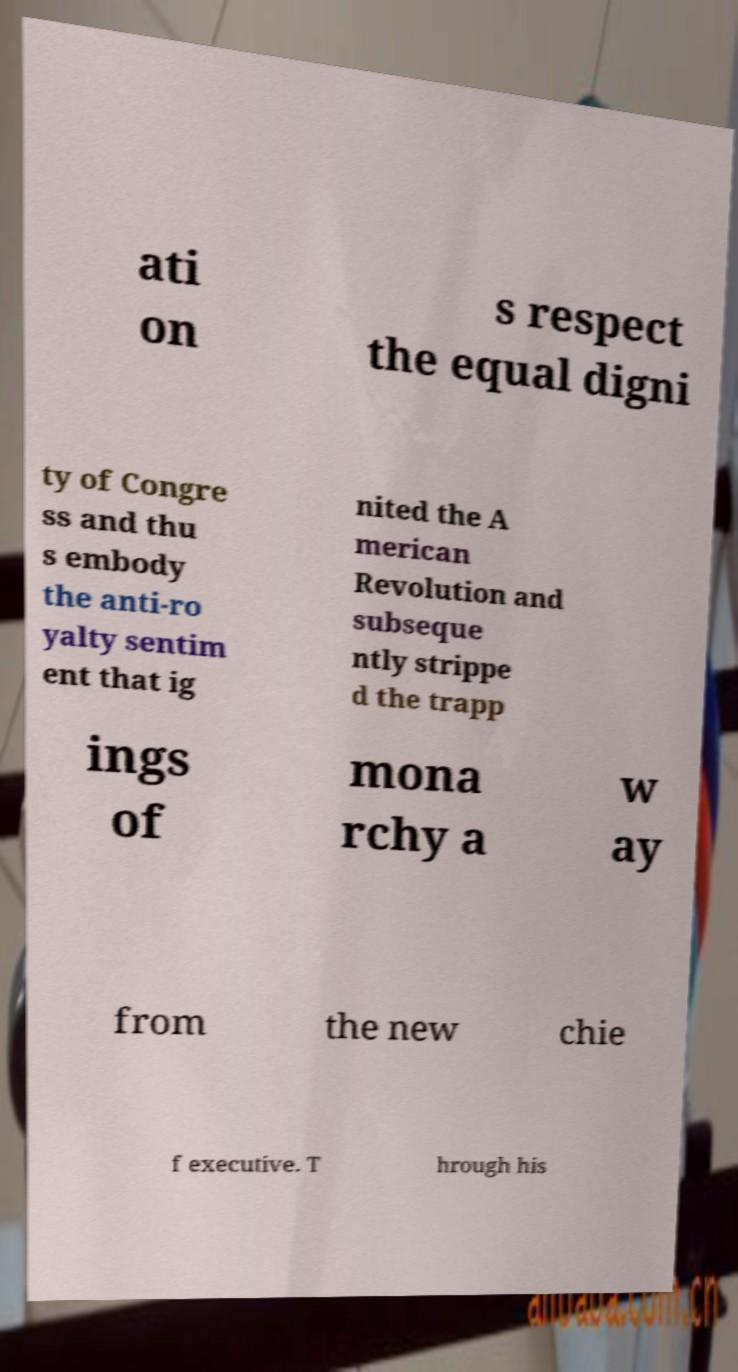Please identify and transcribe the text found in this image. ati on s respect the equal digni ty of Congre ss and thu s embody the anti-ro yalty sentim ent that ig nited the A merican Revolution and subseque ntly strippe d the trapp ings of mona rchy a w ay from the new chie f executive. T hrough his 